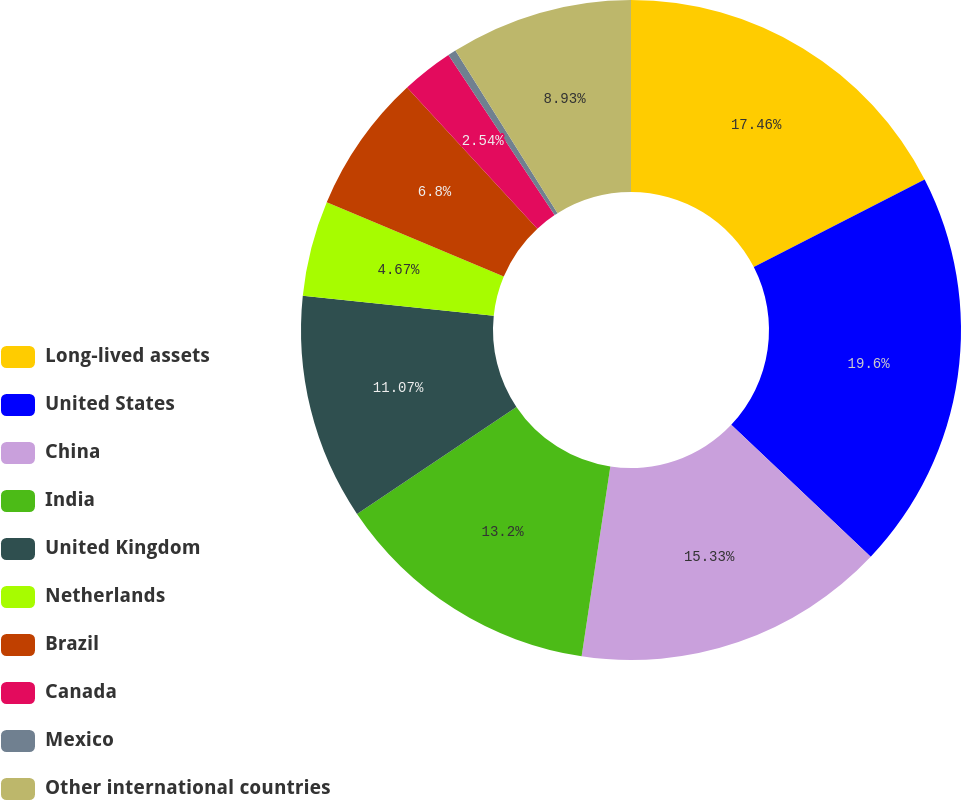<chart> <loc_0><loc_0><loc_500><loc_500><pie_chart><fcel>Long-lived assets<fcel>United States<fcel>China<fcel>India<fcel>United Kingdom<fcel>Netherlands<fcel>Brazil<fcel>Canada<fcel>Mexico<fcel>Other international countries<nl><fcel>17.46%<fcel>19.6%<fcel>15.33%<fcel>13.2%<fcel>11.07%<fcel>4.67%<fcel>6.8%<fcel>2.54%<fcel>0.4%<fcel>8.93%<nl></chart> 